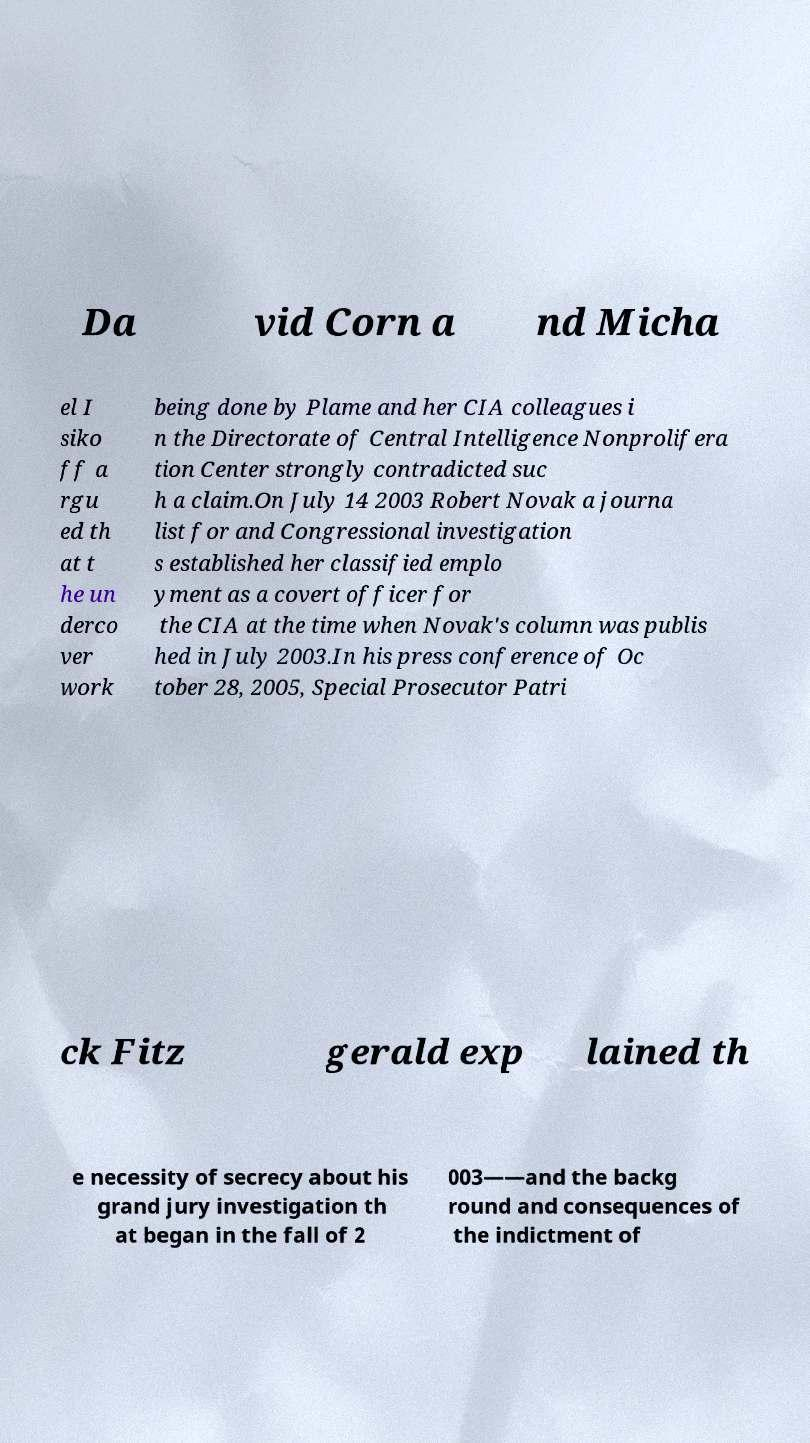Could you extract and type out the text from this image? Da vid Corn a nd Micha el I siko ff a rgu ed th at t he un derco ver work being done by Plame and her CIA colleagues i n the Directorate of Central Intelligence Nonprolifera tion Center strongly contradicted suc h a claim.On July 14 2003 Robert Novak a journa list for and Congressional investigation s established her classified emplo yment as a covert officer for the CIA at the time when Novak's column was publis hed in July 2003.In his press conference of Oc tober 28, 2005, Special Prosecutor Patri ck Fitz gerald exp lained th e necessity of secrecy about his grand jury investigation th at began in the fall of 2 003——and the backg round and consequences of the indictment of 